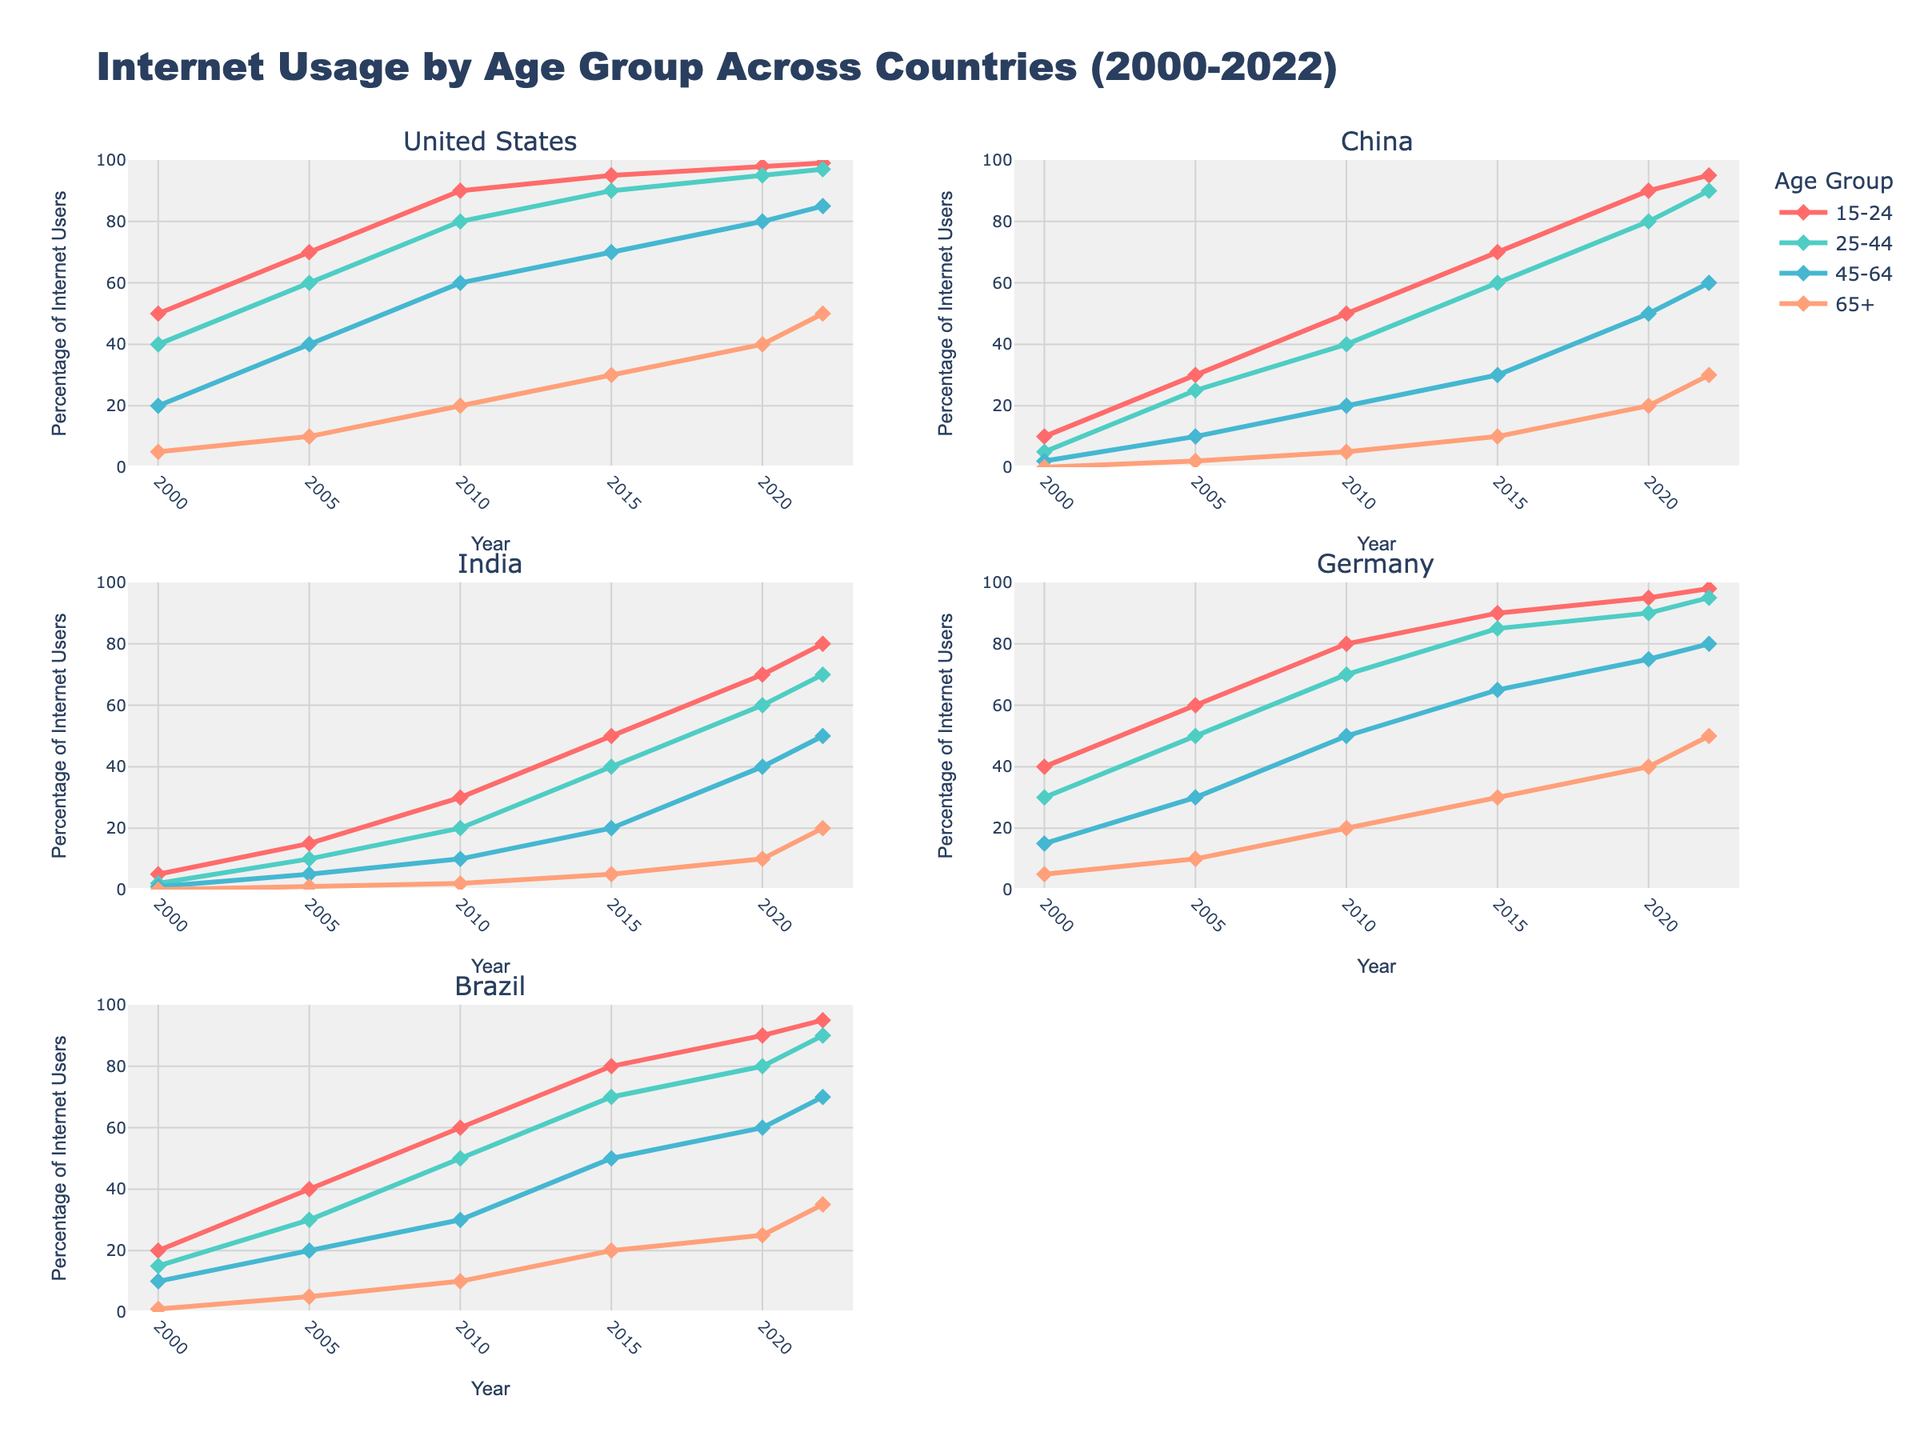What is the overall trend in internet usage among the 15-24 age group across all countries between 2000 and 2022? The overall trend for the 15-24 age group shows a steady increase in internet usage across all countries from 2000 to 2022. The figure shows that by 2022, internet usage in this age group has reached high percentages in all countries listed.
Answer: Steady increase Which country had the highest percentage of internet users in the 65+ age group in 2022? By looking at the 2022 data within the figure for each country in the 65+ age group, Germany has the highest percentage of internet users.
Answer: Germany How did the percentage of internet users in the 25-44 age group in China change from 2000 to 2022? According to the figure, in 2000, the percentage was 5%. By 2022, it had risen to 90%. This shows a significant increase over the period.
Answer: Significant increase Compare the percentage of internet users in the 45-64 age group in India and Brazil in 2010. Which country had a higher percentage? In 2010, the percentage of internet users in the 45-64 age group in Brazil was 30%, while in India it was 10%. Therefore, Brazil had a higher percentage.
Answer: Brazil What is the difference in the percentage of internet users in the 15-24 age group between the United States and India in 2022? From the 2022 data, the percentage of internet users in the 15-24 age group is 99% for the United States and 80% for India. The difference is 99% - 80% = 19%.
Answer: 19% What is the overall trend in internet usage among the 65+ age group in the United States from 2000 to 2022? The trend for the 65+ age group in the United States shows a consistent increase in internet usage from 5% in 2000 to 50% in 2022, according to the figure.
Answer: Consistent increase Which country showed the greatest improvement in internet usage in the 25-44 age group between 2000 and 2022? By comparing the 2000 and 2022 data for the 25-44 age group across all countries, China shows the greatest improvement from 5% to 90%.
Answer: China Among the 45-64 age group, which country had the lowest percentage of internet users in 2022? The lowest percentage of internet users in the 45-64 age group in 2022 is found in India, with a percentage of 50%.
Answer: India Between 2015 and 2020, which country showed the largest increase in internet usage in the 15-24 age group? Comparing the data from 2015 to 2020 for the 15-24 age group in the figure, India showed the largest increase from 50% to 70%.
Answer: India 